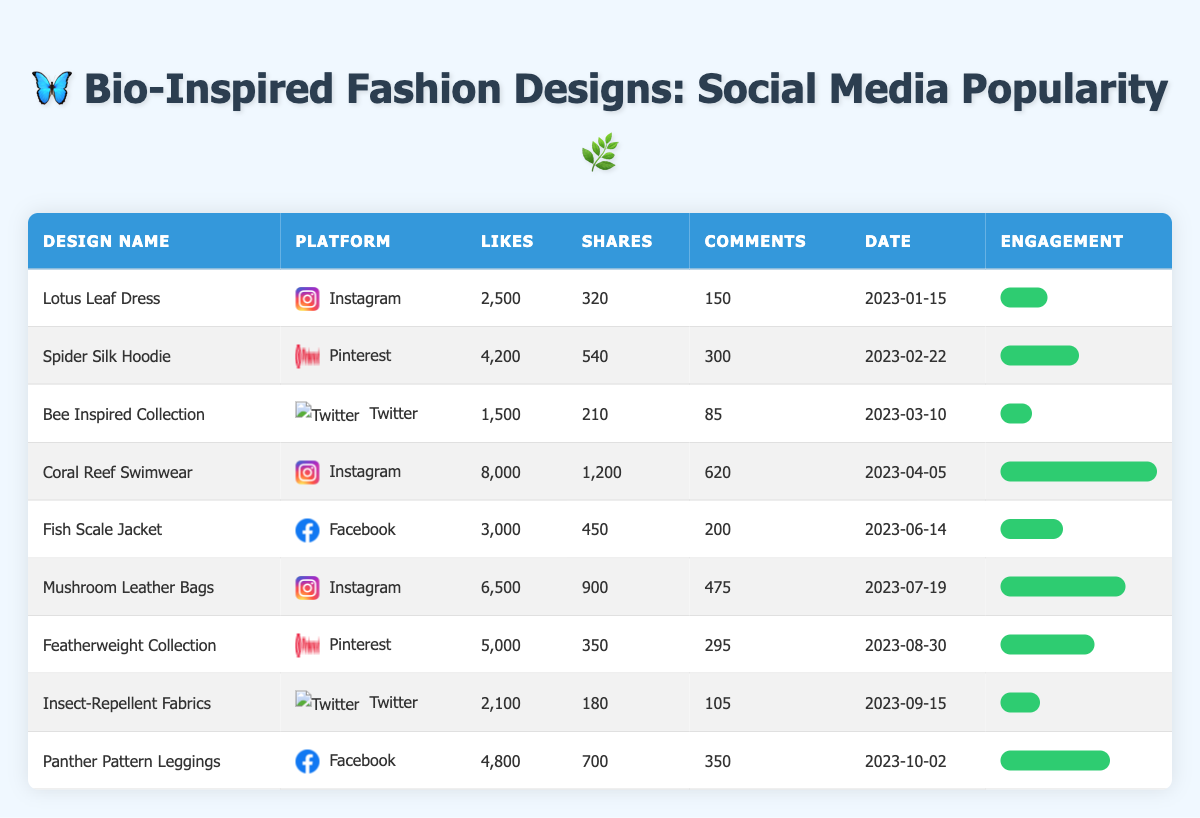What is the total number of likes for all designs on Instagram? From the table, the likes for Instagram designs are: Lotus Leaf Dress (2500), Coral Reef Swimwear (8000), and Mushroom Leather Bags (6500). Adding these together gives 2500 + 8000 + 6500 = 17000.
Answer: 17000 Which design received the highest number of shares? The shares for each design are as follows: Lotus Leaf Dress (320), Spider Silk Hoodie (540), Bee Inspired Collection (210), Coral Reef Swimwear (1200), Fish Scale Jacket (450), Mushroom Leather Bags (900), Featherweight Collection (350), Insect-Repellent Fabrics (180), Panther Pattern Leggings (700). The maximum number of shares is 1200 for Coral Reef Swimwear.
Answer: Coral Reef Swimwear How many designs had more than 500 likes? By reviewing the likes column, the designs with likes above 500 are: Lotus Leaf Dress (2500), Spider Silk Hoodie (4200), Coral Reef Swimwear (8000), Fish Scale Jacket (3000), Mushroom Leather Bags (6500), Featherweight Collection (5000), Panther Pattern Leggings (4800). There are 7 designs.
Answer: 7 Is the Insect-Repellent Fabrics design more popular than the Bee Inspired Collection in terms of total engagement (likes + shares + comments)? Calculate the total engagement: Insect-Repellent Fabrics: likes (2100) + shares (180) + comments (105) = 2385. Bee Inspired Collection: likes (1500) + shares (210) + comments (85) = 1795. Comparing these totals shows that 2385 is greater than 1795.
Answer: Yes What is the average number of comments received by designs across all platforms? Total comments for all designs are: 150 + 300 + 85 + 620 + 200 + 475 + 295 + 105 + 350 = 2280. There are 9 designs, so the average comments are 2280 / 9 = 253.33.
Answer: 253.33 Which platform had the design with the fewest likes? The design with the fewest likes is the Bee Inspired Collection on Twitter with 1500 likes. Comparing other platforms shows that they all have more likes than this design.
Answer: Twitter Which design had the most engagement based on the highest percentage of likes, shares, and comments? To find engagement percentage: Coral Reef Swimwear has the highest engagement bar (100%), which indicates it has the most engagement compared to all designs, reflecting its likes, shares, and comments metrics.
Answer: Coral Reef Swimwear How many designs had more shares than likes? By comparing the shares and likes across designs, we find that no designs had more shares (320, 540, 210, 1200, 450, 900, 350, 180, 700) than likes, since the lowest likes is 1500. Thus, it indicates all had shares below likes.
Answer: 0 